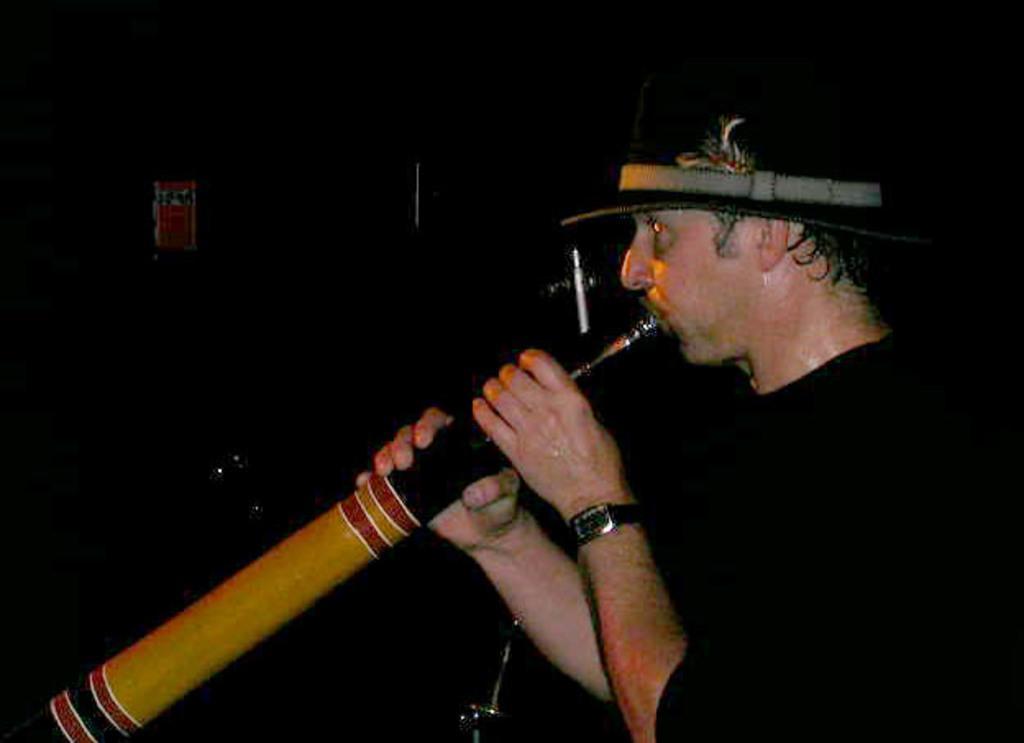In one or two sentences, can you explain what this image depicts? In this image a man wearing black dress and hat is playing a musical instrument. The background is dark. 